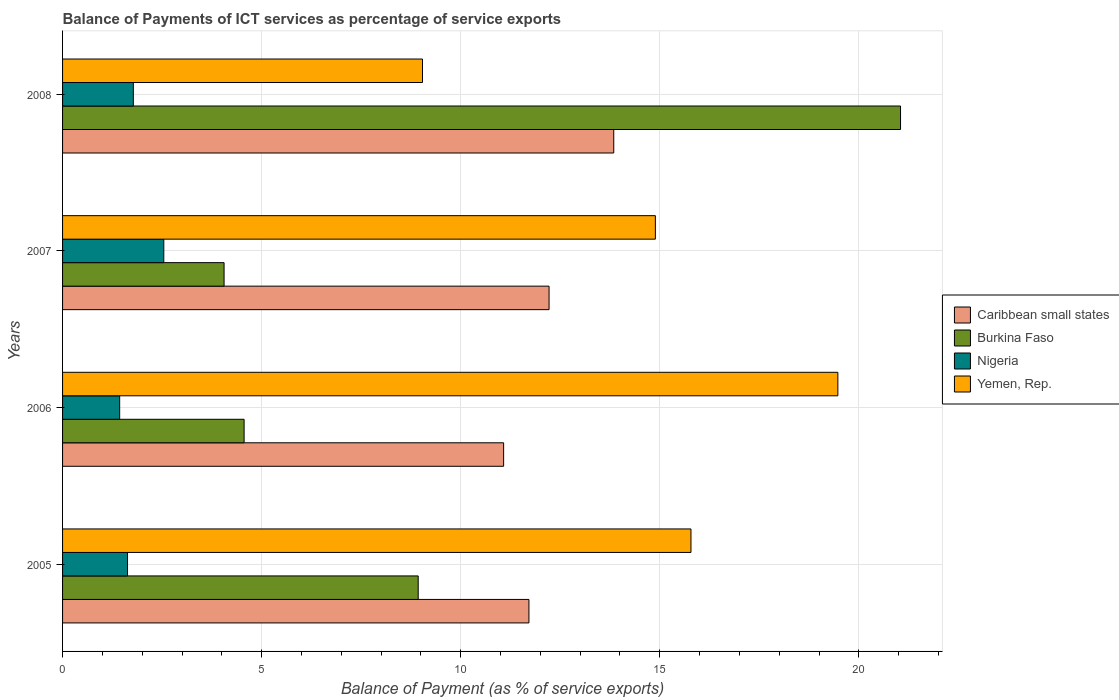How many different coloured bars are there?
Ensure brevity in your answer.  4. How many groups of bars are there?
Ensure brevity in your answer.  4. Are the number of bars per tick equal to the number of legend labels?
Your response must be concise. Yes. How many bars are there on the 4th tick from the top?
Keep it short and to the point. 4. How many bars are there on the 4th tick from the bottom?
Your answer should be very brief. 4. What is the label of the 1st group of bars from the top?
Keep it short and to the point. 2008. In how many cases, is the number of bars for a given year not equal to the number of legend labels?
Your answer should be compact. 0. What is the balance of payments of ICT services in Nigeria in 2006?
Offer a terse response. 1.43. Across all years, what is the maximum balance of payments of ICT services in Yemen, Rep.?
Offer a very short reply. 19.47. Across all years, what is the minimum balance of payments of ICT services in Nigeria?
Provide a succinct answer. 1.43. In which year was the balance of payments of ICT services in Burkina Faso maximum?
Make the answer very short. 2008. What is the total balance of payments of ICT services in Nigeria in the graph?
Provide a short and direct response. 7.39. What is the difference between the balance of payments of ICT services in Caribbean small states in 2005 and that in 2006?
Keep it short and to the point. 0.64. What is the difference between the balance of payments of ICT services in Nigeria in 2005 and the balance of payments of ICT services in Yemen, Rep. in 2007?
Give a very brief answer. -13.26. What is the average balance of payments of ICT services in Yemen, Rep. per year?
Offer a very short reply. 14.8. In the year 2006, what is the difference between the balance of payments of ICT services in Nigeria and balance of payments of ICT services in Yemen, Rep.?
Provide a short and direct response. -18.04. In how many years, is the balance of payments of ICT services in Caribbean small states greater than 5 %?
Give a very brief answer. 4. What is the ratio of the balance of payments of ICT services in Burkina Faso in 2007 to that in 2008?
Offer a terse response. 0.19. Is the balance of payments of ICT services in Nigeria in 2007 less than that in 2008?
Ensure brevity in your answer.  No. What is the difference between the highest and the second highest balance of payments of ICT services in Caribbean small states?
Your answer should be compact. 1.62. What is the difference between the highest and the lowest balance of payments of ICT services in Yemen, Rep.?
Provide a short and direct response. 10.43. Is it the case that in every year, the sum of the balance of payments of ICT services in Burkina Faso and balance of payments of ICT services in Yemen, Rep. is greater than the sum of balance of payments of ICT services in Caribbean small states and balance of payments of ICT services in Nigeria?
Your answer should be compact. No. What does the 3rd bar from the top in 2007 represents?
Your answer should be very brief. Burkina Faso. What does the 3rd bar from the bottom in 2005 represents?
Make the answer very short. Nigeria. Is it the case that in every year, the sum of the balance of payments of ICT services in Nigeria and balance of payments of ICT services in Yemen, Rep. is greater than the balance of payments of ICT services in Caribbean small states?
Provide a succinct answer. No. How many bars are there?
Give a very brief answer. 16. Are all the bars in the graph horizontal?
Provide a succinct answer. Yes. How many years are there in the graph?
Provide a succinct answer. 4. What is the difference between two consecutive major ticks on the X-axis?
Your answer should be very brief. 5. What is the title of the graph?
Your answer should be very brief. Balance of Payments of ICT services as percentage of service exports. What is the label or title of the X-axis?
Give a very brief answer. Balance of Payment (as % of service exports). What is the Balance of Payment (as % of service exports) in Caribbean small states in 2005?
Offer a terse response. 11.71. What is the Balance of Payment (as % of service exports) of Burkina Faso in 2005?
Your answer should be compact. 8.93. What is the Balance of Payment (as % of service exports) of Nigeria in 2005?
Your response must be concise. 1.63. What is the Balance of Payment (as % of service exports) in Yemen, Rep. in 2005?
Offer a terse response. 15.78. What is the Balance of Payment (as % of service exports) in Caribbean small states in 2006?
Keep it short and to the point. 11.08. What is the Balance of Payment (as % of service exports) of Burkina Faso in 2006?
Ensure brevity in your answer.  4.56. What is the Balance of Payment (as % of service exports) in Nigeria in 2006?
Ensure brevity in your answer.  1.43. What is the Balance of Payment (as % of service exports) in Yemen, Rep. in 2006?
Your response must be concise. 19.47. What is the Balance of Payment (as % of service exports) of Caribbean small states in 2007?
Provide a short and direct response. 12.22. What is the Balance of Payment (as % of service exports) in Burkina Faso in 2007?
Ensure brevity in your answer.  4.06. What is the Balance of Payment (as % of service exports) of Nigeria in 2007?
Your response must be concise. 2.54. What is the Balance of Payment (as % of service exports) in Yemen, Rep. in 2007?
Your answer should be very brief. 14.89. What is the Balance of Payment (as % of service exports) of Caribbean small states in 2008?
Ensure brevity in your answer.  13.84. What is the Balance of Payment (as % of service exports) of Burkina Faso in 2008?
Ensure brevity in your answer.  21.05. What is the Balance of Payment (as % of service exports) in Nigeria in 2008?
Offer a terse response. 1.78. What is the Balance of Payment (as % of service exports) of Yemen, Rep. in 2008?
Your response must be concise. 9.04. Across all years, what is the maximum Balance of Payment (as % of service exports) in Caribbean small states?
Provide a succinct answer. 13.84. Across all years, what is the maximum Balance of Payment (as % of service exports) of Burkina Faso?
Provide a short and direct response. 21.05. Across all years, what is the maximum Balance of Payment (as % of service exports) of Nigeria?
Your response must be concise. 2.54. Across all years, what is the maximum Balance of Payment (as % of service exports) of Yemen, Rep.?
Provide a succinct answer. 19.47. Across all years, what is the minimum Balance of Payment (as % of service exports) in Caribbean small states?
Provide a short and direct response. 11.08. Across all years, what is the minimum Balance of Payment (as % of service exports) of Burkina Faso?
Provide a succinct answer. 4.06. Across all years, what is the minimum Balance of Payment (as % of service exports) in Nigeria?
Your answer should be very brief. 1.43. Across all years, what is the minimum Balance of Payment (as % of service exports) of Yemen, Rep.?
Provide a short and direct response. 9.04. What is the total Balance of Payment (as % of service exports) of Caribbean small states in the graph?
Offer a very short reply. 48.85. What is the total Balance of Payment (as % of service exports) in Burkina Faso in the graph?
Ensure brevity in your answer.  38.59. What is the total Balance of Payment (as % of service exports) of Nigeria in the graph?
Offer a very short reply. 7.39. What is the total Balance of Payment (as % of service exports) in Yemen, Rep. in the graph?
Your response must be concise. 59.18. What is the difference between the Balance of Payment (as % of service exports) in Caribbean small states in 2005 and that in 2006?
Provide a succinct answer. 0.64. What is the difference between the Balance of Payment (as % of service exports) of Burkina Faso in 2005 and that in 2006?
Provide a short and direct response. 4.37. What is the difference between the Balance of Payment (as % of service exports) of Nigeria in 2005 and that in 2006?
Your answer should be very brief. 0.2. What is the difference between the Balance of Payment (as % of service exports) of Yemen, Rep. in 2005 and that in 2006?
Provide a succinct answer. -3.69. What is the difference between the Balance of Payment (as % of service exports) in Caribbean small states in 2005 and that in 2007?
Offer a terse response. -0.51. What is the difference between the Balance of Payment (as % of service exports) in Burkina Faso in 2005 and that in 2007?
Your answer should be compact. 4.88. What is the difference between the Balance of Payment (as % of service exports) in Nigeria in 2005 and that in 2007?
Offer a terse response. -0.91. What is the difference between the Balance of Payment (as % of service exports) of Yemen, Rep. in 2005 and that in 2007?
Provide a succinct answer. 0.89. What is the difference between the Balance of Payment (as % of service exports) of Caribbean small states in 2005 and that in 2008?
Give a very brief answer. -2.13. What is the difference between the Balance of Payment (as % of service exports) of Burkina Faso in 2005 and that in 2008?
Your answer should be compact. -12.11. What is the difference between the Balance of Payment (as % of service exports) in Nigeria in 2005 and that in 2008?
Offer a terse response. -0.15. What is the difference between the Balance of Payment (as % of service exports) of Yemen, Rep. in 2005 and that in 2008?
Your answer should be very brief. 6.74. What is the difference between the Balance of Payment (as % of service exports) of Caribbean small states in 2006 and that in 2007?
Your response must be concise. -1.14. What is the difference between the Balance of Payment (as % of service exports) of Burkina Faso in 2006 and that in 2007?
Keep it short and to the point. 0.5. What is the difference between the Balance of Payment (as % of service exports) of Nigeria in 2006 and that in 2007?
Provide a succinct answer. -1.11. What is the difference between the Balance of Payment (as % of service exports) of Yemen, Rep. in 2006 and that in 2007?
Your answer should be very brief. 4.58. What is the difference between the Balance of Payment (as % of service exports) in Caribbean small states in 2006 and that in 2008?
Ensure brevity in your answer.  -2.77. What is the difference between the Balance of Payment (as % of service exports) of Burkina Faso in 2006 and that in 2008?
Offer a very short reply. -16.49. What is the difference between the Balance of Payment (as % of service exports) in Nigeria in 2006 and that in 2008?
Offer a very short reply. -0.34. What is the difference between the Balance of Payment (as % of service exports) of Yemen, Rep. in 2006 and that in 2008?
Ensure brevity in your answer.  10.43. What is the difference between the Balance of Payment (as % of service exports) of Caribbean small states in 2007 and that in 2008?
Offer a very short reply. -1.62. What is the difference between the Balance of Payment (as % of service exports) in Burkina Faso in 2007 and that in 2008?
Your answer should be very brief. -16.99. What is the difference between the Balance of Payment (as % of service exports) in Nigeria in 2007 and that in 2008?
Make the answer very short. 0.76. What is the difference between the Balance of Payment (as % of service exports) of Yemen, Rep. in 2007 and that in 2008?
Offer a terse response. 5.85. What is the difference between the Balance of Payment (as % of service exports) in Caribbean small states in 2005 and the Balance of Payment (as % of service exports) in Burkina Faso in 2006?
Your answer should be compact. 7.15. What is the difference between the Balance of Payment (as % of service exports) of Caribbean small states in 2005 and the Balance of Payment (as % of service exports) of Nigeria in 2006?
Your response must be concise. 10.28. What is the difference between the Balance of Payment (as % of service exports) of Caribbean small states in 2005 and the Balance of Payment (as % of service exports) of Yemen, Rep. in 2006?
Give a very brief answer. -7.76. What is the difference between the Balance of Payment (as % of service exports) in Burkina Faso in 2005 and the Balance of Payment (as % of service exports) in Nigeria in 2006?
Ensure brevity in your answer.  7.5. What is the difference between the Balance of Payment (as % of service exports) in Burkina Faso in 2005 and the Balance of Payment (as % of service exports) in Yemen, Rep. in 2006?
Make the answer very short. -10.54. What is the difference between the Balance of Payment (as % of service exports) of Nigeria in 2005 and the Balance of Payment (as % of service exports) of Yemen, Rep. in 2006?
Your answer should be compact. -17.84. What is the difference between the Balance of Payment (as % of service exports) of Caribbean small states in 2005 and the Balance of Payment (as % of service exports) of Burkina Faso in 2007?
Provide a short and direct response. 7.66. What is the difference between the Balance of Payment (as % of service exports) of Caribbean small states in 2005 and the Balance of Payment (as % of service exports) of Nigeria in 2007?
Give a very brief answer. 9.17. What is the difference between the Balance of Payment (as % of service exports) in Caribbean small states in 2005 and the Balance of Payment (as % of service exports) in Yemen, Rep. in 2007?
Your answer should be compact. -3.18. What is the difference between the Balance of Payment (as % of service exports) in Burkina Faso in 2005 and the Balance of Payment (as % of service exports) in Nigeria in 2007?
Make the answer very short. 6.39. What is the difference between the Balance of Payment (as % of service exports) in Burkina Faso in 2005 and the Balance of Payment (as % of service exports) in Yemen, Rep. in 2007?
Your answer should be very brief. -5.96. What is the difference between the Balance of Payment (as % of service exports) of Nigeria in 2005 and the Balance of Payment (as % of service exports) of Yemen, Rep. in 2007?
Provide a succinct answer. -13.26. What is the difference between the Balance of Payment (as % of service exports) of Caribbean small states in 2005 and the Balance of Payment (as % of service exports) of Burkina Faso in 2008?
Your answer should be compact. -9.33. What is the difference between the Balance of Payment (as % of service exports) of Caribbean small states in 2005 and the Balance of Payment (as % of service exports) of Nigeria in 2008?
Provide a succinct answer. 9.94. What is the difference between the Balance of Payment (as % of service exports) of Caribbean small states in 2005 and the Balance of Payment (as % of service exports) of Yemen, Rep. in 2008?
Provide a short and direct response. 2.67. What is the difference between the Balance of Payment (as % of service exports) in Burkina Faso in 2005 and the Balance of Payment (as % of service exports) in Nigeria in 2008?
Give a very brief answer. 7.15. What is the difference between the Balance of Payment (as % of service exports) of Burkina Faso in 2005 and the Balance of Payment (as % of service exports) of Yemen, Rep. in 2008?
Offer a terse response. -0.11. What is the difference between the Balance of Payment (as % of service exports) of Nigeria in 2005 and the Balance of Payment (as % of service exports) of Yemen, Rep. in 2008?
Your answer should be very brief. -7.41. What is the difference between the Balance of Payment (as % of service exports) in Caribbean small states in 2006 and the Balance of Payment (as % of service exports) in Burkina Faso in 2007?
Offer a very short reply. 7.02. What is the difference between the Balance of Payment (as % of service exports) in Caribbean small states in 2006 and the Balance of Payment (as % of service exports) in Nigeria in 2007?
Make the answer very short. 8.54. What is the difference between the Balance of Payment (as % of service exports) in Caribbean small states in 2006 and the Balance of Payment (as % of service exports) in Yemen, Rep. in 2007?
Your response must be concise. -3.81. What is the difference between the Balance of Payment (as % of service exports) in Burkina Faso in 2006 and the Balance of Payment (as % of service exports) in Nigeria in 2007?
Offer a very short reply. 2.02. What is the difference between the Balance of Payment (as % of service exports) in Burkina Faso in 2006 and the Balance of Payment (as % of service exports) in Yemen, Rep. in 2007?
Offer a terse response. -10.33. What is the difference between the Balance of Payment (as % of service exports) of Nigeria in 2006 and the Balance of Payment (as % of service exports) of Yemen, Rep. in 2007?
Provide a short and direct response. -13.46. What is the difference between the Balance of Payment (as % of service exports) of Caribbean small states in 2006 and the Balance of Payment (as % of service exports) of Burkina Faso in 2008?
Your answer should be compact. -9.97. What is the difference between the Balance of Payment (as % of service exports) in Caribbean small states in 2006 and the Balance of Payment (as % of service exports) in Nigeria in 2008?
Keep it short and to the point. 9.3. What is the difference between the Balance of Payment (as % of service exports) in Caribbean small states in 2006 and the Balance of Payment (as % of service exports) in Yemen, Rep. in 2008?
Ensure brevity in your answer.  2.04. What is the difference between the Balance of Payment (as % of service exports) of Burkina Faso in 2006 and the Balance of Payment (as % of service exports) of Nigeria in 2008?
Your response must be concise. 2.78. What is the difference between the Balance of Payment (as % of service exports) of Burkina Faso in 2006 and the Balance of Payment (as % of service exports) of Yemen, Rep. in 2008?
Provide a short and direct response. -4.48. What is the difference between the Balance of Payment (as % of service exports) in Nigeria in 2006 and the Balance of Payment (as % of service exports) in Yemen, Rep. in 2008?
Make the answer very short. -7.61. What is the difference between the Balance of Payment (as % of service exports) in Caribbean small states in 2007 and the Balance of Payment (as % of service exports) in Burkina Faso in 2008?
Your answer should be very brief. -8.83. What is the difference between the Balance of Payment (as % of service exports) of Caribbean small states in 2007 and the Balance of Payment (as % of service exports) of Nigeria in 2008?
Your answer should be very brief. 10.44. What is the difference between the Balance of Payment (as % of service exports) in Caribbean small states in 2007 and the Balance of Payment (as % of service exports) in Yemen, Rep. in 2008?
Keep it short and to the point. 3.18. What is the difference between the Balance of Payment (as % of service exports) of Burkina Faso in 2007 and the Balance of Payment (as % of service exports) of Nigeria in 2008?
Provide a short and direct response. 2.28. What is the difference between the Balance of Payment (as % of service exports) of Burkina Faso in 2007 and the Balance of Payment (as % of service exports) of Yemen, Rep. in 2008?
Make the answer very short. -4.98. What is the difference between the Balance of Payment (as % of service exports) in Nigeria in 2007 and the Balance of Payment (as % of service exports) in Yemen, Rep. in 2008?
Make the answer very short. -6.5. What is the average Balance of Payment (as % of service exports) in Caribbean small states per year?
Provide a short and direct response. 12.21. What is the average Balance of Payment (as % of service exports) of Burkina Faso per year?
Offer a terse response. 9.65. What is the average Balance of Payment (as % of service exports) of Nigeria per year?
Make the answer very short. 1.85. What is the average Balance of Payment (as % of service exports) of Yemen, Rep. per year?
Your answer should be compact. 14.8. In the year 2005, what is the difference between the Balance of Payment (as % of service exports) in Caribbean small states and Balance of Payment (as % of service exports) in Burkina Faso?
Provide a short and direct response. 2.78. In the year 2005, what is the difference between the Balance of Payment (as % of service exports) of Caribbean small states and Balance of Payment (as % of service exports) of Nigeria?
Give a very brief answer. 10.08. In the year 2005, what is the difference between the Balance of Payment (as % of service exports) in Caribbean small states and Balance of Payment (as % of service exports) in Yemen, Rep.?
Your response must be concise. -4.07. In the year 2005, what is the difference between the Balance of Payment (as % of service exports) in Burkina Faso and Balance of Payment (as % of service exports) in Nigeria?
Keep it short and to the point. 7.3. In the year 2005, what is the difference between the Balance of Payment (as % of service exports) in Burkina Faso and Balance of Payment (as % of service exports) in Yemen, Rep.?
Provide a succinct answer. -6.85. In the year 2005, what is the difference between the Balance of Payment (as % of service exports) of Nigeria and Balance of Payment (as % of service exports) of Yemen, Rep.?
Your response must be concise. -14.15. In the year 2006, what is the difference between the Balance of Payment (as % of service exports) of Caribbean small states and Balance of Payment (as % of service exports) of Burkina Faso?
Ensure brevity in your answer.  6.52. In the year 2006, what is the difference between the Balance of Payment (as % of service exports) of Caribbean small states and Balance of Payment (as % of service exports) of Nigeria?
Provide a short and direct response. 9.64. In the year 2006, what is the difference between the Balance of Payment (as % of service exports) of Caribbean small states and Balance of Payment (as % of service exports) of Yemen, Rep.?
Offer a very short reply. -8.39. In the year 2006, what is the difference between the Balance of Payment (as % of service exports) of Burkina Faso and Balance of Payment (as % of service exports) of Nigeria?
Provide a succinct answer. 3.13. In the year 2006, what is the difference between the Balance of Payment (as % of service exports) of Burkina Faso and Balance of Payment (as % of service exports) of Yemen, Rep.?
Give a very brief answer. -14.91. In the year 2006, what is the difference between the Balance of Payment (as % of service exports) of Nigeria and Balance of Payment (as % of service exports) of Yemen, Rep.?
Make the answer very short. -18.04. In the year 2007, what is the difference between the Balance of Payment (as % of service exports) in Caribbean small states and Balance of Payment (as % of service exports) in Burkina Faso?
Your answer should be compact. 8.16. In the year 2007, what is the difference between the Balance of Payment (as % of service exports) in Caribbean small states and Balance of Payment (as % of service exports) in Nigeria?
Keep it short and to the point. 9.68. In the year 2007, what is the difference between the Balance of Payment (as % of service exports) of Caribbean small states and Balance of Payment (as % of service exports) of Yemen, Rep.?
Provide a short and direct response. -2.67. In the year 2007, what is the difference between the Balance of Payment (as % of service exports) in Burkina Faso and Balance of Payment (as % of service exports) in Nigeria?
Your response must be concise. 1.51. In the year 2007, what is the difference between the Balance of Payment (as % of service exports) in Burkina Faso and Balance of Payment (as % of service exports) in Yemen, Rep.?
Provide a succinct answer. -10.83. In the year 2007, what is the difference between the Balance of Payment (as % of service exports) in Nigeria and Balance of Payment (as % of service exports) in Yemen, Rep.?
Your answer should be very brief. -12.35. In the year 2008, what is the difference between the Balance of Payment (as % of service exports) in Caribbean small states and Balance of Payment (as % of service exports) in Burkina Faso?
Offer a very short reply. -7.2. In the year 2008, what is the difference between the Balance of Payment (as % of service exports) of Caribbean small states and Balance of Payment (as % of service exports) of Nigeria?
Ensure brevity in your answer.  12.07. In the year 2008, what is the difference between the Balance of Payment (as % of service exports) in Caribbean small states and Balance of Payment (as % of service exports) in Yemen, Rep.?
Ensure brevity in your answer.  4.8. In the year 2008, what is the difference between the Balance of Payment (as % of service exports) of Burkina Faso and Balance of Payment (as % of service exports) of Nigeria?
Ensure brevity in your answer.  19.27. In the year 2008, what is the difference between the Balance of Payment (as % of service exports) of Burkina Faso and Balance of Payment (as % of service exports) of Yemen, Rep.?
Provide a succinct answer. 12.01. In the year 2008, what is the difference between the Balance of Payment (as % of service exports) of Nigeria and Balance of Payment (as % of service exports) of Yemen, Rep.?
Offer a terse response. -7.26. What is the ratio of the Balance of Payment (as % of service exports) in Caribbean small states in 2005 to that in 2006?
Your answer should be very brief. 1.06. What is the ratio of the Balance of Payment (as % of service exports) of Burkina Faso in 2005 to that in 2006?
Your response must be concise. 1.96. What is the ratio of the Balance of Payment (as % of service exports) in Nigeria in 2005 to that in 2006?
Offer a terse response. 1.14. What is the ratio of the Balance of Payment (as % of service exports) of Yemen, Rep. in 2005 to that in 2006?
Make the answer very short. 0.81. What is the ratio of the Balance of Payment (as % of service exports) of Caribbean small states in 2005 to that in 2007?
Provide a short and direct response. 0.96. What is the ratio of the Balance of Payment (as % of service exports) of Burkina Faso in 2005 to that in 2007?
Your response must be concise. 2.2. What is the ratio of the Balance of Payment (as % of service exports) in Nigeria in 2005 to that in 2007?
Offer a terse response. 0.64. What is the ratio of the Balance of Payment (as % of service exports) in Yemen, Rep. in 2005 to that in 2007?
Provide a short and direct response. 1.06. What is the ratio of the Balance of Payment (as % of service exports) of Caribbean small states in 2005 to that in 2008?
Keep it short and to the point. 0.85. What is the ratio of the Balance of Payment (as % of service exports) in Burkina Faso in 2005 to that in 2008?
Make the answer very short. 0.42. What is the ratio of the Balance of Payment (as % of service exports) of Nigeria in 2005 to that in 2008?
Your answer should be very brief. 0.92. What is the ratio of the Balance of Payment (as % of service exports) of Yemen, Rep. in 2005 to that in 2008?
Offer a very short reply. 1.75. What is the ratio of the Balance of Payment (as % of service exports) of Caribbean small states in 2006 to that in 2007?
Offer a very short reply. 0.91. What is the ratio of the Balance of Payment (as % of service exports) of Burkina Faso in 2006 to that in 2007?
Your response must be concise. 1.12. What is the ratio of the Balance of Payment (as % of service exports) of Nigeria in 2006 to that in 2007?
Provide a short and direct response. 0.56. What is the ratio of the Balance of Payment (as % of service exports) in Yemen, Rep. in 2006 to that in 2007?
Give a very brief answer. 1.31. What is the ratio of the Balance of Payment (as % of service exports) in Caribbean small states in 2006 to that in 2008?
Your response must be concise. 0.8. What is the ratio of the Balance of Payment (as % of service exports) of Burkina Faso in 2006 to that in 2008?
Make the answer very short. 0.22. What is the ratio of the Balance of Payment (as % of service exports) in Nigeria in 2006 to that in 2008?
Your answer should be compact. 0.81. What is the ratio of the Balance of Payment (as % of service exports) of Yemen, Rep. in 2006 to that in 2008?
Make the answer very short. 2.15. What is the ratio of the Balance of Payment (as % of service exports) in Caribbean small states in 2007 to that in 2008?
Offer a terse response. 0.88. What is the ratio of the Balance of Payment (as % of service exports) in Burkina Faso in 2007 to that in 2008?
Offer a very short reply. 0.19. What is the ratio of the Balance of Payment (as % of service exports) of Nigeria in 2007 to that in 2008?
Your response must be concise. 1.43. What is the ratio of the Balance of Payment (as % of service exports) in Yemen, Rep. in 2007 to that in 2008?
Your answer should be compact. 1.65. What is the difference between the highest and the second highest Balance of Payment (as % of service exports) in Caribbean small states?
Your response must be concise. 1.62. What is the difference between the highest and the second highest Balance of Payment (as % of service exports) in Burkina Faso?
Keep it short and to the point. 12.11. What is the difference between the highest and the second highest Balance of Payment (as % of service exports) of Nigeria?
Provide a short and direct response. 0.76. What is the difference between the highest and the second highest Balance of Payment (as % of service exports) in Yemen, Rep.?
Give a very brief answer. 3.69. What is the difference between the highest and the lowest Balance of Payment (as % of service exports) of Caribbean small states?
Offer a very short reply. 2.77. What is the difference between the highest and the lowest Balance of Payment (as % of service exports) in Burkina Faso?
Give a very brief answer. 16.99. What is the difference between the highest and the lowest Balance of Payment (as % of service exports) of Nigeria?
Your answer should be very brief. 1.11. What is the difference between the highest and the lowest Balance of Payment (as % of service exports) in Yemen, Rep.?
Your answer should be very brief. 10.43. 